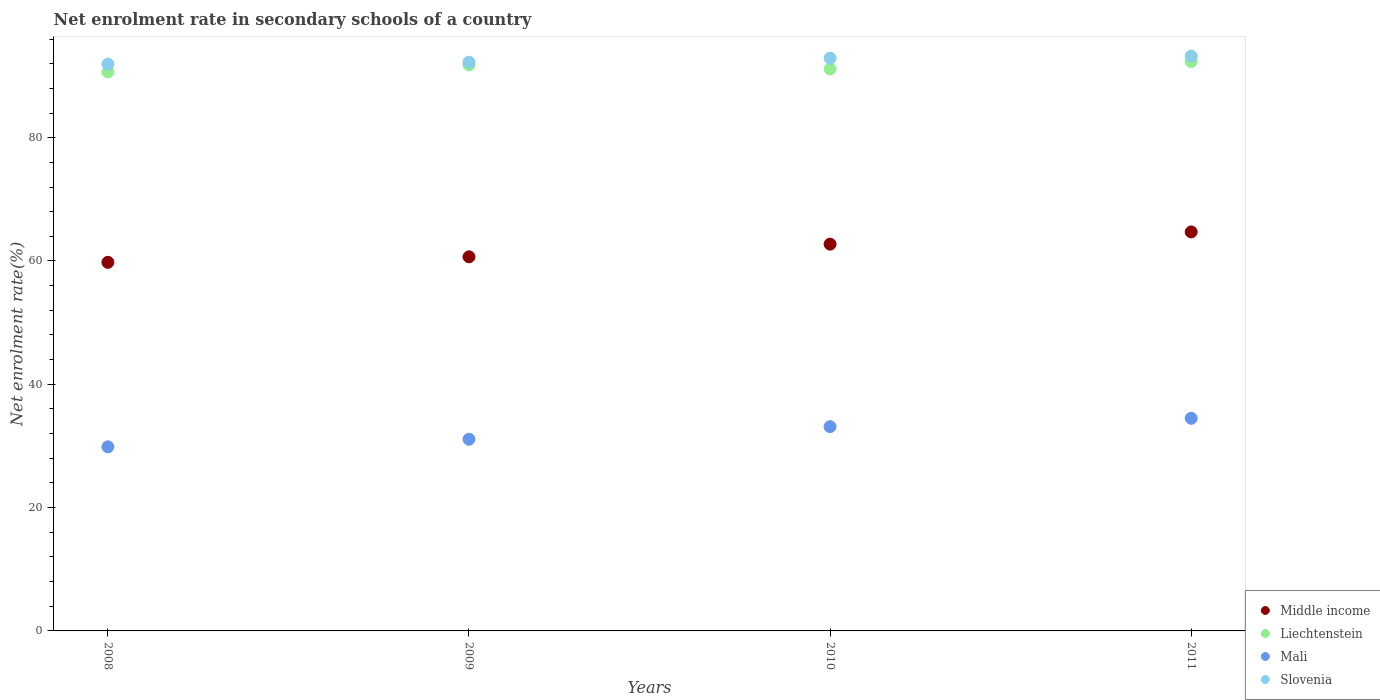How many different coloured dotlines are there?
Your response must be concise. 4. What is the net enrolment rate in secondary schools in Liechtenstein in 2009?
Keep it short and to the point. 91.83. Across all years, what is the maximum net enrolment rate in secondary schools in Liechtenstein?
Offer a very short reply. 92.36. Across all years, what is the minimum net enrolment rate in secondary schools in Mali?
Make the answer very short. 29.86. In which year was the net enrolment rate in secondary schools in Liechtenstein minimum?
Provide a succinct answer. 2008. What is the total net enrolment rate in secondary schools in Slovenia in the graph?
Offer a terse response. 370.3. What is the difference between the net enrolment rate in secondary schools in Liechtenstein in 2008 and that in 2010?
Provide a succinct answer. -0.49. What is the difference between the net enrolment rate in secondary schools in Mali in 2009 and the net enrolment rate in secondary schools in Liechtenstein in 2008?
Offer a terse response. -59.57. What is the average net enrolment rate in secondary schools in Liechtenstein per year?
Offer a terse response. 91.5. In the year 2010, what is the difference between the net enrolment rate in secondary schools in Middle income and net enrolment rate in secondary schools in Liechtenstein?
Keep it short and to the point. -28.42. What is the ratio of the net enrolment rate in secondary schools in Slovenia in 2010 to that in 2011?
Offer a terse response. 1. Is the difference between the net enrolment rate in secondary schools in Middle income in 2009 and 2010 greater than the difference between the net enrolment rate in secondary schools in Liechtenstein in 2009 and 2010?
Offer a very short reply. No. What is the difference between the highest and the second highest net enrolment rate in secondary schools in Mali?
Make the answer very short. 1.36. What is the difference between the highest and the lowest net enrolment rate in secondary schools in Slovenia?
Make the answer very short. 1.3. Is the sum of the net enrolment rate in secondary schools in Middle income in 2008 and 2011 greater than the maximum net enrolment rate in secondary schools in Liechtenstein across all years?
Provide a short and direct response. Yes. Does the net enrolment rate in secondary schools in Slovenia monotonically increase over the years?
Provide a short and direct response. Yes. Is the net enrolment rate in secondary schools in Slovenia strictly greater than the net enrolment rate in secondary schools in Liechtenstein over the years?
Offer a very short reply. Yes. How many years are there in the graph?
Your answer should be compact. 4. Are the values on the major ticks of Y-axis written in scientific E-notation?
Your answer should be very brief. No. Does the graph contain any zero values?
Keep it short and to the point. No. What is the title of the graph?
Your answer should be very brief. Net enrolment rate in secondary schools of a country. Does "Lebanon" appear as one of the legend labels in the graph?
Give a very brief answer. No. What is the label or title of the Y-axis?
Give a very brief answer. Net enrolment rate(%). What is the Net enrolment rate(%) in Middle income in 2008?
Provide a succinct answer. 59.78. What is the Net enrolment rate(%) in Liechtenstein in 2008?
Your response must be concise. 90.66. What is the Net enrolment rate(%) of Mali in 2008?
Offer a terse response. 29.86. What is the Net enrolment rate(%) in Slovenia in 2008?
Your answer should be compact. 91.93. What is the Net enrolment rate(%) in Middle income in 2009?
Offer a terse response. 60.68. What is the Net enrolment rate(%) of Liechtenstein in 2009?
Your response must be concise. 91.83. What is the Net enrolment rate(%) in Mali in 2009?
Make the answer very short. 31.09. What is the Net enrolment rate(%) in Slovenia in 2009?
Provide a succinct answer. 92.24. What is the Net enrolment rate(%) of Middle income in 2010?
Ensure brevity in your answer.  62.73. What is the Net enrolment rate(%) of Liechtenstein in 2010?
Your response must be concise. 91.15. What is the Net enrolment rate(%) of Mali in 2010?
Your answer should be very brief. 33.13. What is the Net enrolment rate(%) in Slovenia in 2010?
Your answer should be very brief. 92.89. What is the Net enrolment rate(%) of Middle income in 2011?
Provide a succinct answer. 64.72. What is the Net enrolment rate(%) in Liechtenstein in 2011?
Provide a short and direct response. 92.36. What is the Net enrolment rate(%) of Mali in 2011?
Give a very brief answer. 34.49. What is the Net enrolment rate(%) of Slovenia in 2011?
Provide a succinct answer. 93.23. Across all years, what is the maximum Net enrolment rate(%) in Middle income?
Your response must be concise. 64.72. Across all years, what is the maximum Net enrolment rate(%) in Liechtenstein?
Make the answer very short. 92.36. Across all years, what is the maximum Net enrolment rate(%) in Mali?
Make the answer very short. 34.49. Across all years, what is the maximum Net enrolment rate(%) of Slovenia?
Keep it short and to the point. 93.23. Across all years, what is the minimum Net enrolment rate(%) in Middle income?
Your answer should be very brief. 59.78. Across all years, what is the minimum Net enrolment rate(%) of Liechtenstein?
Make the answer very short. 90.66. Across all years, what is the minimum Net enrolment rate(%) in Mali?
Provide a short and direct response. 29.86. Across all years, what is the minimum Net enrolment rate(%) in Slovenia?
Keep it short and to the point. 91.93. What is the total Net enrolment rate(%) in Middle income in the graph?
Your answer should be very brief. 247.9. What is the total Net enrolment rate(%) in Liechtenstein in the graph?
Your answer should be compact. 366. What is the total Net enrolment rate(%) of Mali in the graph?
Your answer should be compact. 128.56. What is the total Net enrolment rate(%) of Slovenia in the graph?
Your response must be concise. 370.3. What is the difference between the Net enrolment rate(%) in Middle income in 2008 and that in 2009?
Keep it short and to the point. -0.89. What is the difference between the Net enrolment rate(%) in Liechtenstein in 2008 and that in 2009?
Offer a terse response. -1.17. What is the difference between the Net enrolment rate(%) in Mali in 2008 and that in 2009?
Provide a short and direct response. -1.23. What is the difference between the Net enrolment rate(%) in Slovenia in 2008 and that in 2009?
Give a very brief answer. -0.31. What is the difference between the Net enrolment rate(%) of Middle income in 2008 and that in 2010?
Your answer should be compact. -2.95. What is the difference between the Net enrolment rate(%) of Liechtenstein in 2008 and that in 2010?
Make the answer very short. -0.49. What is the difference between the Net enrolment rate(%) in Mali in 2008 and that in 2010?
Give a very brief answer. -3.27. What is the difference between the Net enrolment rate(%) of Slovenia in 2008 and that in 2010?
Offer a very short reply. -0.96. What is the difference between the Net enrolment rate(%) in Middle income in 2008 and that in 2011?
Your answer should be very brief. -4.93. What is the difference between the Net enrolment rate(%) of Liechtenstein in 2008 and that in 2011?
Offer a very short reply. -1.7. What is the difference between the Net enrolment rate(%) in Mali in 2008 and that in 2011?
Keep it short and to the point. -4.63. What is the difference between the Net enrolment rate(%) of Slovenia in 2008 and that in 2011?
Make the answer very short. -1.3. What is the difference between the Net enrolment rate(%) in Middle income in 2009 and that in 2010?
Make the answer very short. -2.05. What is the difference between the Net enrolment rate(%) of Liechtenstein in 2009 and that in 2010?
Offer a terse response. 0.67. What is the difference between the Net enrolment rate(%) of Mali in 2009 and that in 2010?
Offer a terse response. -2.05. What is the difference between the Net enrolment rate(%) in Slovenia in 2009 and that in 2010?
Provide a short and direct response. -0.65. What is the difference between the Net enrolment rate(%) in Middle income in 2009 and that in 2011?
Make the answer very short. -4.04. What is the difference between the Net enrolment rate(%) of Liechtenstein in 2009 and that in 2011?
Make the answer very short. -0.54. What is the difference between the Net enrolment rate(%) in Mali in 2009 and that in 2011?
Ensure brevity in your answer.  -3.4. What is the difference between the Net enrolment rate(%) of Slovenia in 2009 and that in 2011?
Your answer should be very brief. -0.99. What is the difference between the Net enrolment rate(%) in Middle income in 2010 and that in 2011?
Offer a very short reply. -1.98. What is the difference between the Net enrolment rate(%) in Liechtenstein in 2010 and that in 2011?
Keep it short and to the point. -1.21. What is the difference between the Net enrolment rate(%) in Mali in 2010 and that in 2011?
Keep it short and to the point. -1.36. What is the difference between the Net enrolment rate(%) in Slovenia in 2010 and that in 2011?
Ensure brevity in your answer.  -0.34. What is the difference between the Net enrolment rate(%) in Middle income in 2008 and the Net enrolment rate(%) in Liechtenstein in 2009?
Provide a short and direct response. -32.04. What is the difference between the Net enrolment rate(%) in Middle income in 2008 and the Net enrolment rate(%) in Mali in 2009?
Make the answer very short. 28.7. What is the difference between the Net enrolment rate(%) in Middle income in 2008 and the Net enrolment rate(%) in Slovenia in 2009?
Your answer should be very brief. -32.46. What is the difference between the Net enrolment rate(%) of Liechtenstein in 2008 and the Net enrolment rate(%) of Mali in 2009?
Provide a short and direct response. 59.57. What is the difference between the Net enrolment rate(%) in Liechtenstein in 2008 and the Net enrolment rate(%) in Slovenia in 2009?
Ensure brevity in your answer.  -1.58. What is the difference between the Net enrolment rate(%) in Mali in 2008 and the Net enrolment rate(%) in Slovenia in 2009?
Provide a short and direct response. -62.38. What is the difference between the Net enrolment rate(%) in Middle income in 2008 and the Net enrolment rate(%) in Liechtenstein in 2010?
Provide a succinct answer. -31.37. What is the difference between the Net enrolment rate(%) of Middle income in 2008 and the Net enrolment rate(%) of Mali in 2010?
Your answer should be compact. 26.65. What is the difference between the Net enrolment rate(%) of Middle income in 2008 and the Net enrolment rate(%) of Slovenia in 2010?
Offer a terse response. -33.11. What is the difference between the Net enrolment rate(%) of Liechtenstein in 2008 and the Net enrolment rate(%) of Mali in 2010?
Your answer should be very brief. 57.53. What is the difference between the Net enrolment rate(%) of Liechtenstein in 2008 and the Net enrolment rate(%) of Slovenia in 2010?
Offer a terse response. -2.23. What is the difference between the Net enrolment rate(%) in Mali in 2008 and the Net enrolment rate(%) in Slovenia in 2010?
Provide a succinct answer. -63.03. What is the difference between the Net enrolment rate(%) of Middle income in 2008 and the Net enrolment rate(%) of Liechtenstein in 2011?
Your answer should be compact. -32.58. What is the difference between the Net enrolment rate(%) in Middle income in 2008 and the Net enrolment rate(%) in Mali in 2011?
Offer a very short reply. 25.29. What is the difference between the Net enrolment rate(%) of Middle income in 2008 and the Net enrolment rate(%) of Slovenia in 2011?
Your answer should be very brief. -33.45. What is the difference between the Net enrolment rate(%) of Liechtenstein in 2008 and the Net enrolment rate(%) of Mali in 2011?
Keep it short and to the point. 56.17. What is the difference between the Net enrolment rate(%) of Liechtenstein in 2008 and the Net enrolment rate(%) of Slovenia in 2011?
Your answer should be compact. -2.57. What is the difference between the Net enrolment rate(%) of Mali in 2008 and the Net enrolment rate(%) of Slovenia in 2011?
Ensure brevity in your answer.  -63.37. What is the difference between the Net enrolment rate(%) in Middle income in 2009 and the Net enrolment rate(%) in Liechtenstein in 2010?
Give a very brief answer. -30.48. What is the difference between the Net enrolment rate(%) of Middle income in 2009 and the Net enrolment rate(%) of Mali in 2010?
Keep it short and to the point. 27.55. What is the difference between the Net enrolment rate(%) of Middle income in 2009 and the Net enrolment rate(%) of Slovenia in 2010?
Offer a terse response. -32.21. What is the difference between the Net enrolment rate(%) in Liechtenstein in 2009 and the Net enrolment rate(%) in Mali in 2010?
Give a very brief answer. 58.7. What is the difference between the Net enrolment rate(%) in Liechtenstein in 2009 and the Net enrolment rate(%) in Slovenia in 2010?
Your answer should be compact. -1.07. What is the difference between the Net enrolment rate(%) in Mali in 2009 and the Net enrolment rate(%) in Slovenia in 2010?
Give a very brief answer. -61.81. What is the difference between the Net enrolment rate(%) in Middle income in 2009 and the Net enrolment rate(%) in Liechtenstein in 2011?
Give a very brief answer. -31.69. What is the difference between the Net enrolment rate(%) in Middle income in 2009 and the Net enrolment rate(%) in Mali in 2011?
Offer a very short reply. 26.19. What is the difference between the Net enrolment rate(%) in Middle income in 2009 and the Net enrolment rate(%) in Slovenia in 2011?
Give a very brief answer. -32.55. What is the difference between the Net enrolment rate(%) of Liechtenstein in 2009 and the Net enrolment rate(%) of Mali in 2011?
Your answer should be compact. 57.34. What is the difference between the Net enrolment rate(%) in Liechtenstein in 2009 and the Net enrolment rate(%) in Slovenia in 2011?
Offer a terse response. -1.4. What is the difference between the Net enrolment rate(%) of Mali in 2009 and the Net enrolment rate(%) of Slovenia in 2011?
Offer a very short reply. -62.15. What is the difference between the Net enrolment rate(%) in Middle income in 2010 and the Net enrolment rate(%) in Liechtenstein in 2011?
Provide a succinct answer. -29.63. What is the difference between the Net enrolment rate(%) of Middle income in 2010 and the Net enrolment rate(%) of Mali in 2011?
Make the answer very short. 28.24. What is the difference between the Net enrolment rate(%) in Middle income in 2010 and the Net enrolment rate(%) in Slovenia in 2011?
Your response must be concise. -30.5. What is the difference between the Net enrolment rate(%) in Liechtenstein in 2010 and the Net enrolment rate(%) in Mali in 2011?
Make the answer very short. 56.67. What is the difference between the Net enrolment rate(%) of Liechtenstein in 2010 and the Net enrolment rate(%) of Slovenia in 2011?
Ensure brevity in your answer.  -2.08. What is the difference between the Net enrolment rate(%) in Mali in 2010 and the Net enrolment rate(%) in Slovenia in 2011?
Your answer should be compact. -60.1. What is the average Net enrolment rate(%) in Middle income per year?
Your answer should be compact. 61.98. What is the average Net enrolment rate(%) in Liechtenstein per year?
Offer a terse response. 91.5. What is the average Net enrolment rate(%) of Mali per year?
Ensure brevity in your answer.  32.14. What is the average Net enrolment rate(%) of Slovenia per year?
Your answer should be very brief. 92.57. In the year 2008, what is the difference between the Net enrolment rate(%) of Middle income and Net enrolment rate(%) of Liechtenstein?
Keep it short and to the point. -30.88. In the year 2008, what is the difference between the Net enrolment rate(%) in Middle income and Net enrolment rate(%) in Mali?
Your response must be concise. 29.92. In the year 2008, what is the difference between the Net enrolment rate(%) in Middle income and Net enrolment rate(%) in Slovenia?
Your answer should be compact. -32.15. In the year 2008, what is the difference between the Net enrolment rate(%) of Liechtenstein and Net enrolment rate(%) of Mali?
Give a very brief answer. 60.8. In the year 2008, what is the difference between the Net enrolment rate(%) of Liechtenstein and Net enrolment rate(%) of Slovenia?
Offer a terse response. -1.27. In the year 2008, what is the difference between the Net enrolment rate(%) in Mali and Net enrolment rate(%) in Slovenia?
Provide a short and direct response. -62.07. In the year 2009, what is the difference between the Net enrolment rate(%) of Middle income and Net enrolment rate(%) of Liechtenstein?
Your answer should be compact. -31.15. In the year 2009, what is the difference between the Net enrolment rate(%) in Middle income and Net enrolment rate(%) in Mali?
Your answer should be very brief. 29.59. In the year 2009, what is the difference between the Net enrolment rate(%) of Middle income and Net enrolment rate(%) of Slovenia?
Provide a succinct answer. -31.57. In the year 2009, what is the difference between the Net enrolment rate(%) in Liechtenstein and Net enrolment rate(%) in Mali?
Make the answer very short. 60.74. In the year 2009, what is the difference between the Net enrolment rate(%) in Liechtenstein and Net enrolment rate(%) in Slovenia?
Provide a succinct answer. -0.42. In the year 2009, what is the difference between the Net enrolment rate(%) in Mali and Net enrolment rate(%) in Slovenia?
Your response must be concise. -61.16. In the year 2010, what is the difference between the Net enrolment rate(%) of Middle income and Net enrolment rate(%) of Liechtenstein?
Ensure brevity in your answer.  -28.42. In the year 2010, what is the difference between the Net enrolment rate(%) of Middle income and Net enrolment rate(%) of Mali?
Keep it short and to the point. 29.6. In the year 2010, what is the difference between the Net enrolment rate(%) of Middle income and Net enrolment rate(%) of Slovenia?
Make the answer very short. -30.16. In the year 2010, what is the difference between the Net enrolment rate(%) of Liechtenstein and Net enrolment rate(%) of Mali?
Give a very brief answer. 58.02. In the year 2010, what is the difference between the Net enrolment rate(%) in Liechtenstein and Net enrolment rate(%) in Slovenia?
Your answer should be compact. -1.74. In the year 2010, what is the difference between the Net enrolment rate(%) of Mali and Net enrolment rate(%) of Slovenia?
Provide a short and direct response. -59.76. In the year 2011, what is the difference between the Net enrolment rate(%) of Middle income and Net enrolment rate(%) of Liechtenstein?
Make the answer very short. -27.65. In the year 2011, what is the difference between the Net enrolment rate(%) in Middle income and Net enrolment rate(%) in Mali?
Your answer should be very brief. 30.23. In the year 2011, what is the difference between the Net enrolment rate(%) of Middle income and Net enrolment rate(%) of Slovenia?
Offer a very short reply. -28.52. In the year 2011, what is the difference between the Net enrolment rate(%) of Liechtenstein and Net enrolment rate(%) of Mali?
Ensure brevity in your answer.  57.87. In the year 2011, what is the difference between the Net enrolment rate(%) of Liechtenstein and Net enrolment rate(%) of Slovenia?
Provide a succinct answer. -0.87. In the year 2011, what is the difference between the Net enrolment rate(%) in Mali and Net enrolment rate(%) in Slovenia?
Your answer should be very brief. -58.74. What is the ratio of the Net enrolment rate(%) in Middle income in 2008 to that in 2009?
Make the answer very short. 0.99. What is the ratio of the Net enrolment rate(%) of Liechtenstein in 2008 to that in 2009?
Ensure brevity in your answer.  0.99. What is the ratio of the Net enrolment rate(%) of Mali in 2008 to that in 2009?
Offer a very short reply. 0.96. What is the ratio of the Net enrolment rate(%) in Middle income in 2008 to that in 2010?
Your response must be concise. 0.95. What is the ratio of the Net enrolment rate(%) of Liechtenstein in 2008 to that in 2010?
Give a very brief answer. 0.99. What is the ratio of the Net enrolment rate(%) of Mali in 2008 to that in 2010?
Make the answer very short. 0.9. What is the ratio of the Net enrolment rate(%) in Middle income in 2008 to that in 2011?
Offer a very short reply. 0.92. What is the ratio of the Net enrolment rate(%) of Liechtenstein in 2008 to that in 2011?
Your response must be concise. 0.98. What is the ratio of the Net enrolment rate(%) in Mali in 2008 to that in 2011?
Provide a short and direct response. 0.87. What is the ratio of the Net enrolment rate(%) in Slovenia in 2008 to that in 2011?
Your answer should be compact. 0.99. What is the ratio of the Net enrolment rate(%) in Middle income in 2009 to that in 2010?
Give a very brief answer. 0.97. What is the ratio of the Net enrolment rate(%) in Liechtenstein in 2009 to that in 2010?
Offer a terse response. 1.01. What is the ratio of the Net enrolment rate(%) in Mali in 2009 to that in 2010?
Offer a very short reply. 0.94. What is the ratio of the Net enrolment rate(%) in Middle income in 2009 to that in 2011?
Provide a succinct answer. 0.94. What is the ratio of the Net enrolment rate(%) of Mali in 2009 to that in 2011?
Offer a terse response. 0.9. What is the ratio of the Net enrolment rate(%) in Slovenia in 2009 to that in 2011?
Your answer should be compact. 0.99. What is the ratio of the Net enrolment rate(%) of Middle income in 2010 to that in 2011?
Offer a terse response. 0.97. What is the ratio of the Net enrolment rate(%) of Liechtenstein in 2010 to that in 2011?
Offer a terse response. 0.99. What is the ratio of the Net enrolment rate(%) in Mali in 2010 to that in 2011?
Make the answer very short. 0.96. What is the difference between the highest and the second highest Net enrolment rate(%) of Middle income?
Your answer should be compact. 1.98. What is the difference between the highest and the second highest Net enrolment rate(%) of Liechtenstein?
Provide a short and direct response. 0.54. What is the difference between the highest and the second highest Net enrolment rate(%) of Mali?
Make the answer very short. 1.36. What is the difference between the highest and the second highest Net enrolment rate(%) of Slovenia?
Provide a short and direct response. 0.34. What is the difference between the highest and the lowest Net enrolment rate(%) in Middle income?
Make the answer very short. 4.93. What is the difference between the highest and the lowest Net enrolment rate(%) in Liechtenstein?
Keep it short and to the point. 1.7. What is the difference between the highest and the lowest Net enrolment rate(%) in Mali?
Ensure brevity in your answer.  4.63. What is the difference between the highest and the lowest Net enrolment rate(%) of Slovenia?
Your answer should be very brief. 1.3. 